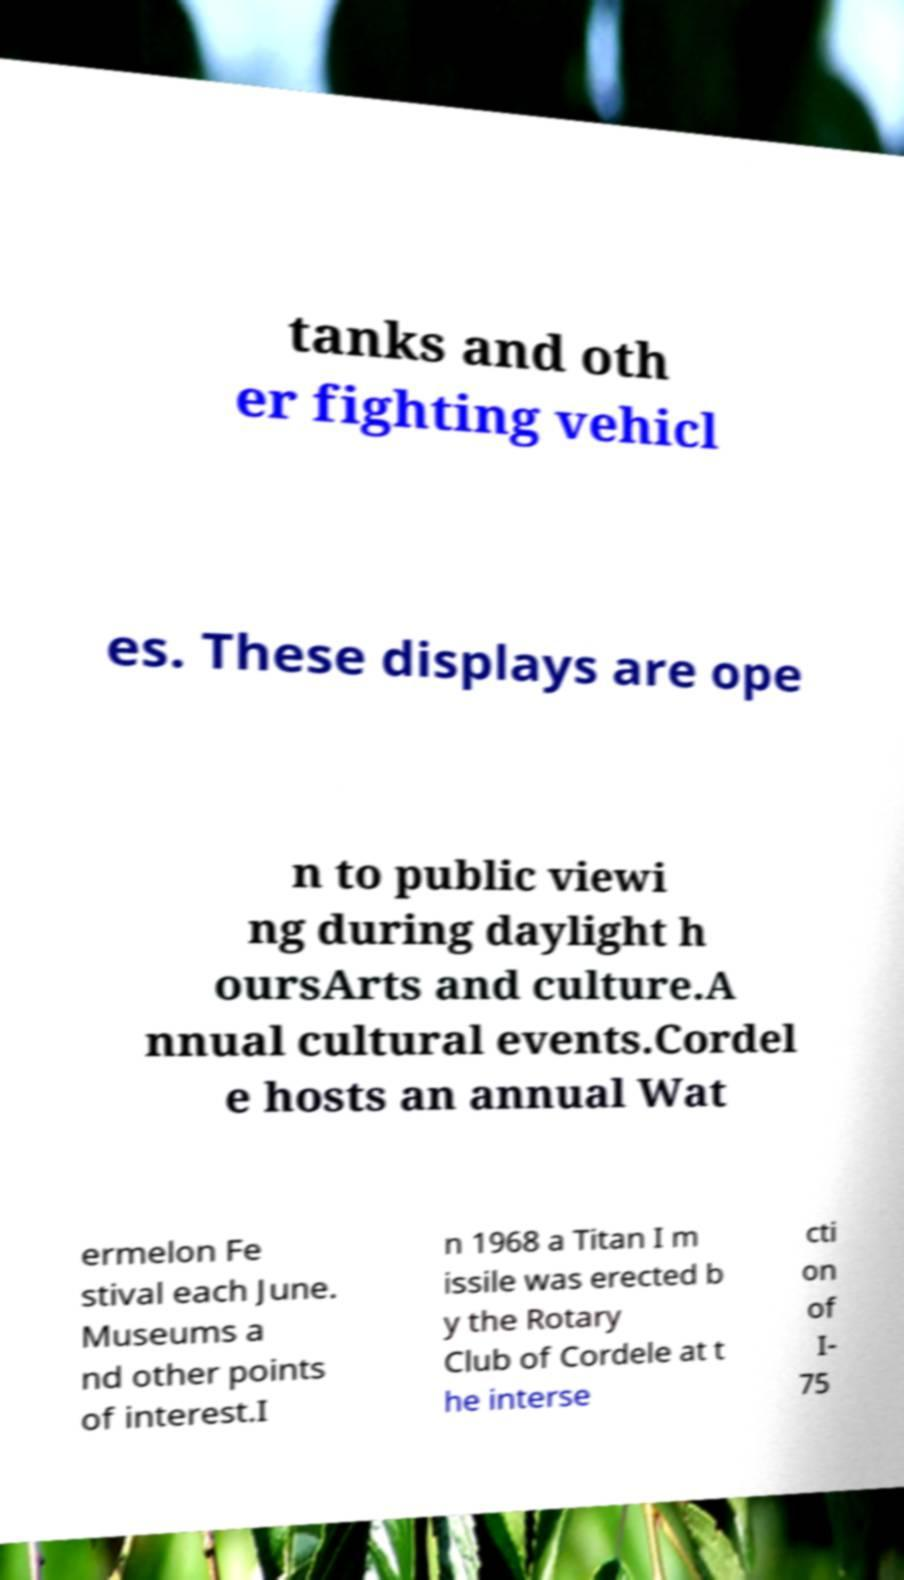Can you read and provide the text displayed in the image?This photo seems to have some interesting text. Can you extract and type it out for me? tanks and oth er fighting vehicl es. These displays are ope n to public viewi ng during daylight h oursArts and culture.A nnual cultural events.Cordel e hosts an annual Wat ermelon Fe stival each June. Museums a nd other points of interest.I n 1968 a Titan I m issile was erected b y the Rotary Club of Cordele at t he interse cti on of I- 75 